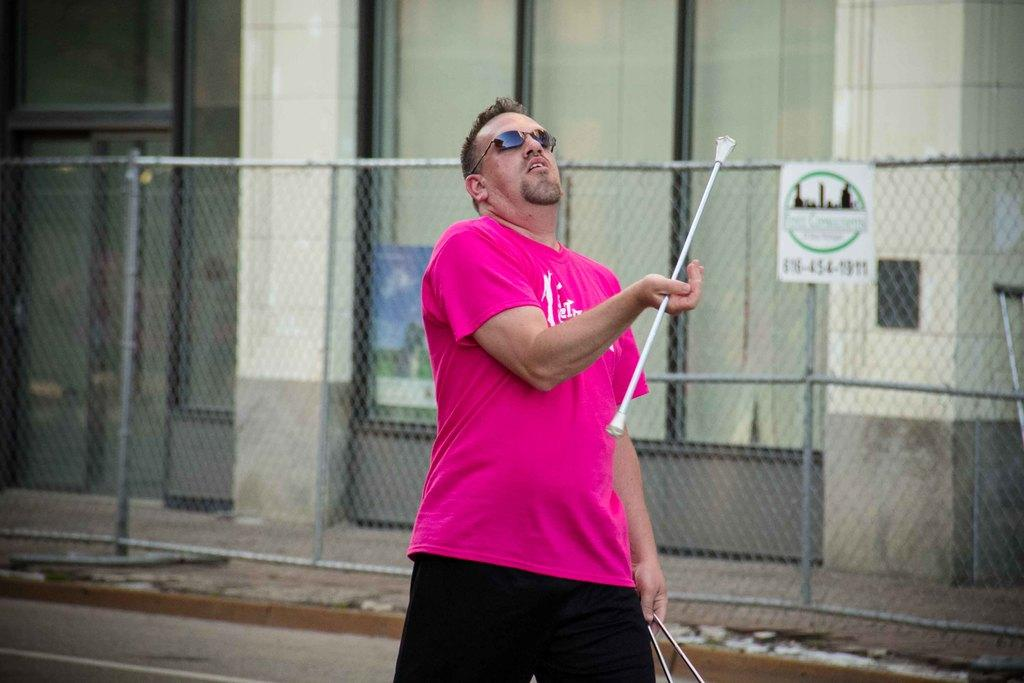What is the man in the image doing? The man is standing in the image and holding sticks. What is the man wearing in the image? The man is wearing a pink t-shirt in the image. What can be seen in the background of the image? In the background of the image, there is a board on a fence, a glass object, a poster, and a wall. What type of elbow can be seen in the image? There is no elbow present in the image. What type of building is depicted in the image? The image does not show a building; it features a man standing with sticks and various objects in the background. 